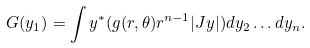<formula> <loc_0><loc_0><loc_500><loc_500>G ( y _ { 1 } ) = \int y ^ { * } ( g ( r , \theta ) r ^ { n - 1 } | J y | ) d y _ { 2 } \dots d y _ { n } .</formula> 